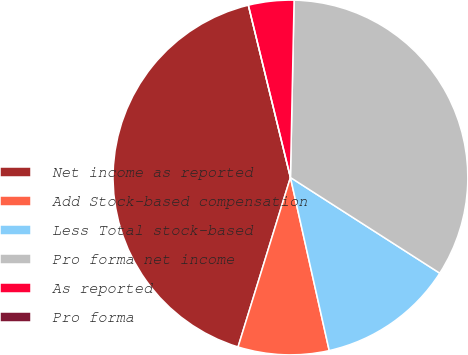Convert chart. <chart><loc_0><loc_0><loc_500><loc_500><pie_chart><fcel>Net income as reported<fcel>Add Stock-based compensation<fcel>Less Total stock-based<fcel>Pro forma net income<fcel>As reported<fcel>Pro forma<nl><fcel>41.41%<fcel>8.28%<fcel>12.42%<fcel>33.74%<fcel>4.14%<fcel>0.0%<nl></chart> 